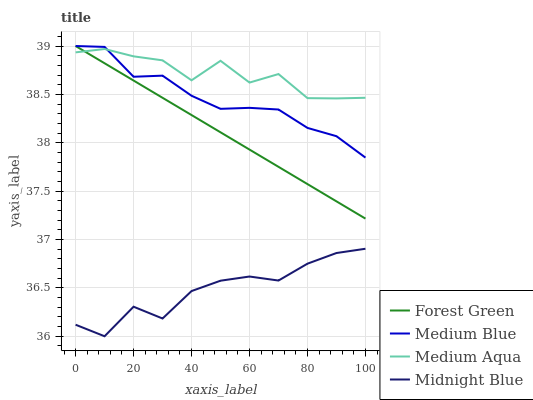Does Forest Green have the minimum area under the curve?
Answer yes or no. No. Does Forest Green have the maximum area under the curve?
Answer yes or no. No. Is Medium Blue the smoothest?
Answer yes or no. No. Is Medium Blue the roughest?
Answer yes or no. No. Does Forest Green have the lowest value?
Answer yes or no. No. Does Midnight Blue have the highest value?
Answer yes or no. No. Is Midnight Blue less than Forest Green?
Answer yes or no. Yes. Is Forest Green greater than Midnight Blue?
Answer yes or no. Yes. Does Midnight Blue intersect Forest Green?
Answer yes or no. No. 